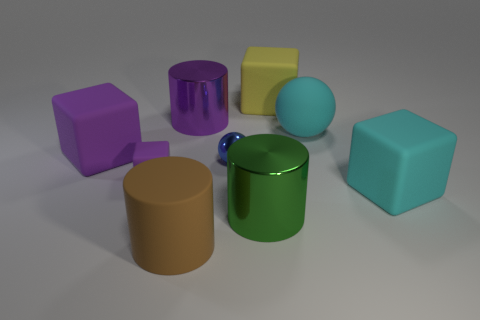Subtract all yellow cylinders. Subtract all red spheres. How many cylinders are left? 3 Subtract all balls. How many objects are left? 7 Add 6 metallic cylinders. How many metallic cylinders are left? 8 Add 1 big red shiny objects. How many big red shiny objects exist? 1 Subtract 0 yellow spheres. How many objects are left? 9 Subtract all small blue metallic balls. Subtract all green cylinders. How many objects are left? 7 